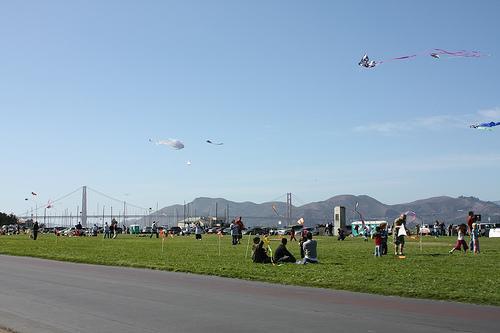How many towers does the bridge have?
Give a very brief answer. 2. 